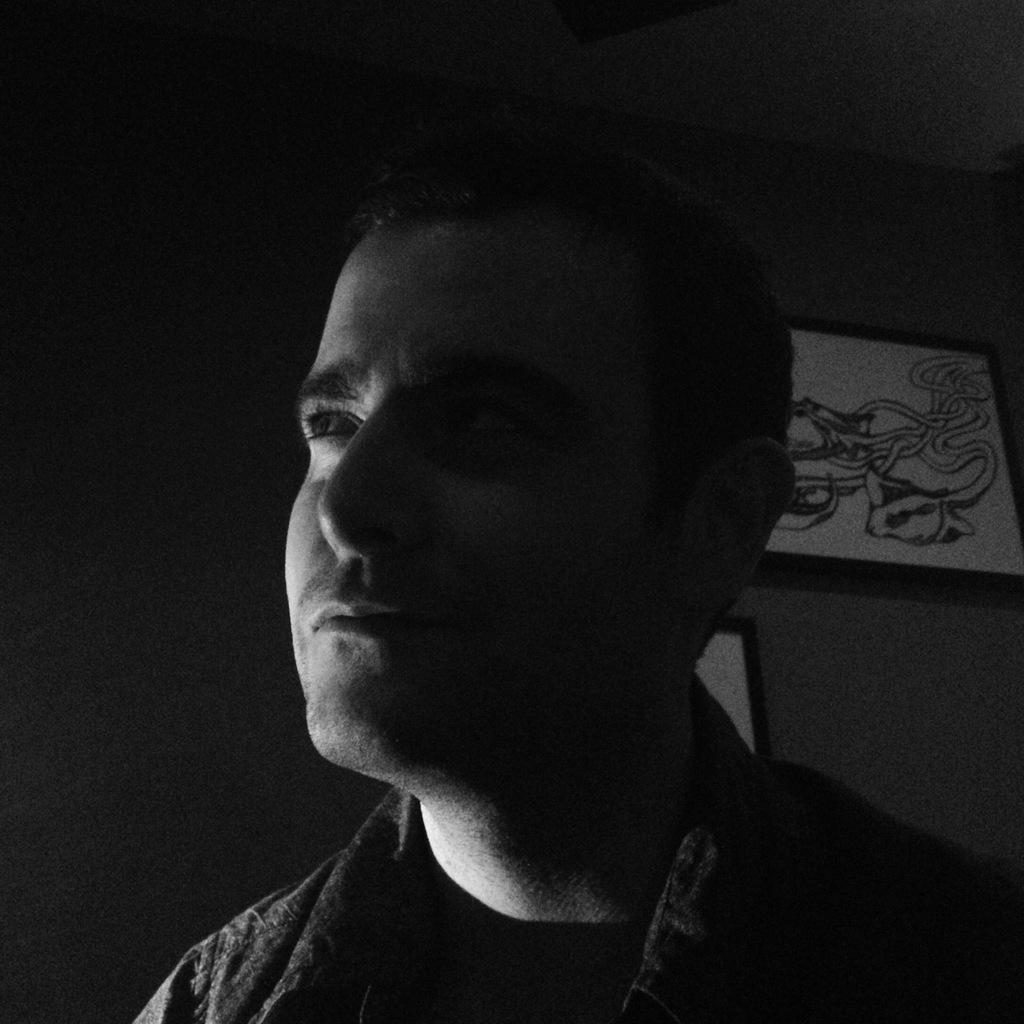Who is present in the image? There is a man in the image. What can be seen in the background of the image? There is a wall in the background of the image. What is attached to the wall? Frames are fixed on the wall. How many lizards are sitting on the man's shoulder in the image? There are no lizards present in the image. What type of reward is the boy receiving in the image? There is no boy or reward present in the image. 